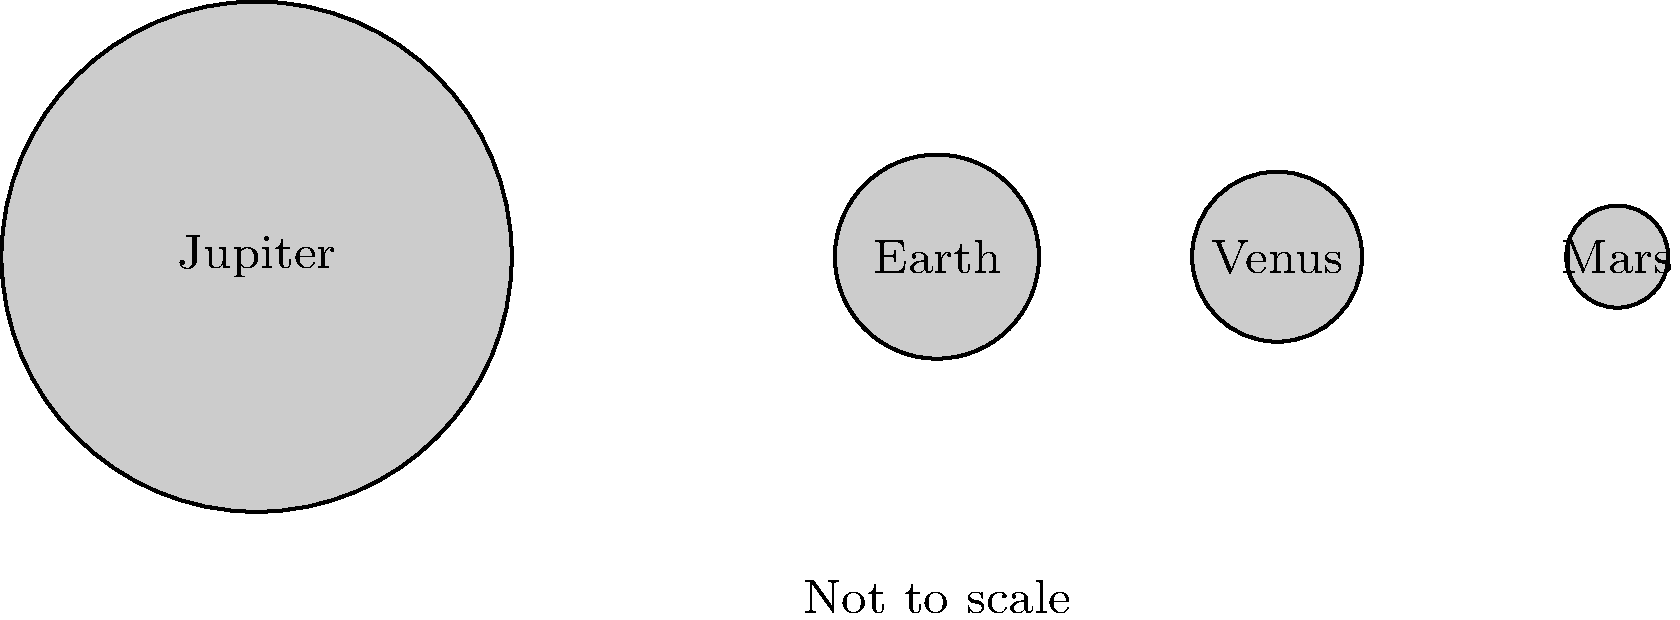In the context of planetary scales, which musical concept could be metaphorically applied to describe the relationship between Jupiter and the terrestrial planets (Earth, Venus, and Mars) shown in the diagram? To answer this question, let's analyze the diagram and draw parallels between astronomy and music:

1. Observe the relative sizes of the planets in the diagram:
   - Jupiter is significantly larger than the other planets.
   - Earth, Venus, and Mars are much smaller and closer in size to each other.

2. In music, we have the concept of a "bass line" or "bass voice":
   - The bass is typically the lowest and often the most powerful voice in a musical arrangement.
   - It provides the foundation and structure for the other voices or instruments.

3. Drawing the parallel:
   - Jupiter, being the largest planet, can be likened to the bass voice in music.
   - The smaller terrestrial planets (Earth, Venus, and Mars) could represent the higher voices or melodies.

4. In Latin American music, which is your area of expertise:
   - The bass line is crucial in many genres, such as salsa, reggaeton, and bossa nova.
   - It often provides the rhythmic and harmonic foundation for the entire piece.

5. Similarly, in our solar system:
   - Jupiter's immense gravitational influence affects the orbits and behavior of smaller bodies.
   - It acts as a protective "shield" for inner planets by deflecting many comets and asteroids.

Therefore, the musical concept that could metaphorically describe this relationship is the "bass line" or "bass voice," with Jupiter playing the role of the powerful, foundational bass in the "solar system orchestra."
Answer: Bass line 